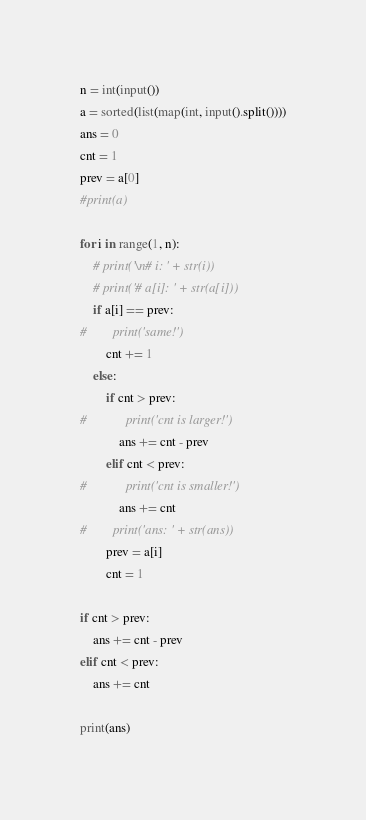Convert code to text. <code><loc_0><loc_0><loc_500><loc_500><_Python_>n = int(input())
a = sorted(list(map(int, input().split())))
ans = 0
cnt = 1
prev = a[0]
#print(a)

for i in range(1, n):
    # print('\n# i: ' + str(i))
    # print('# a[i]: ' + str(a[i]))
    if a[i] == prev:
#        print('same!')
        cnt += 1
    else:
        if cnt > prev:
#            print('cnt is larger!')
            ans += cnt - prev
        elif cnt < prev:
#            print('cnt is smaller!')
            ans += cnt
#        print('ans: ' + str(ans))
        prev = a[i]
        cnt = 1

if cnt > prev:
    ans += cnt - prev
elif cnt < prev:
    ans += cnt

print(ans)

</code> 